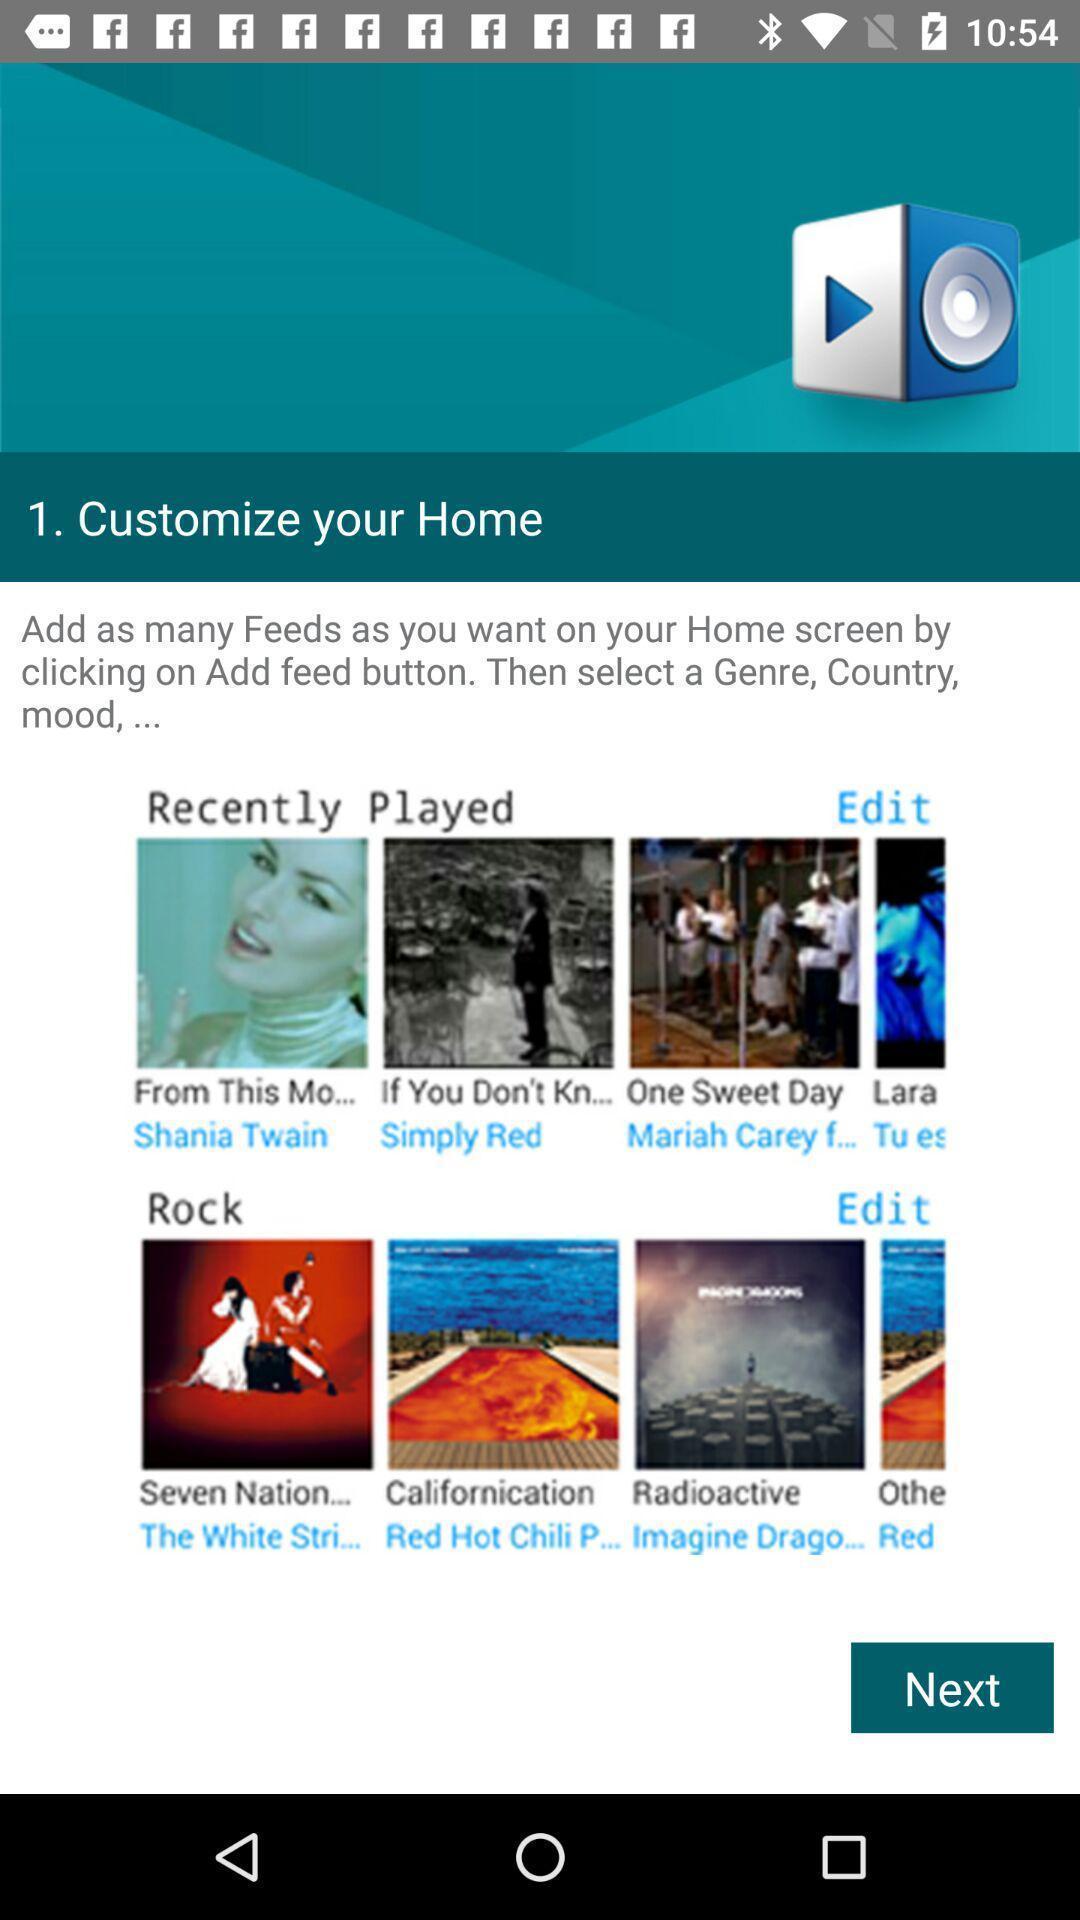Give me a summary of this screen capture. Page showing information from feeds. 